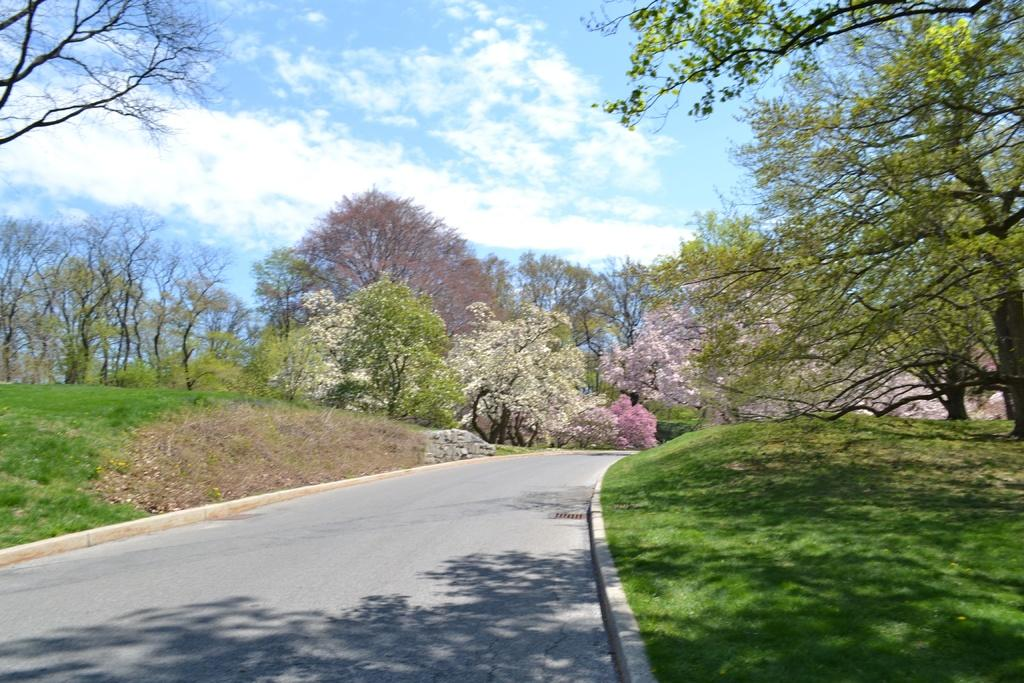What type of vegetation can be seen in the image? There is grass in the image. What else can be seen in the image besides grass? There are trees in the image. What is visible at the top of the image? The sky is visible at the top of the image. What can be seen in the sky? There are clouds in the sky. What degree is the grass in the image? The grass in the image does not have a degree. What type of bucket can be seen in the image? There is no bucket present in the image. 